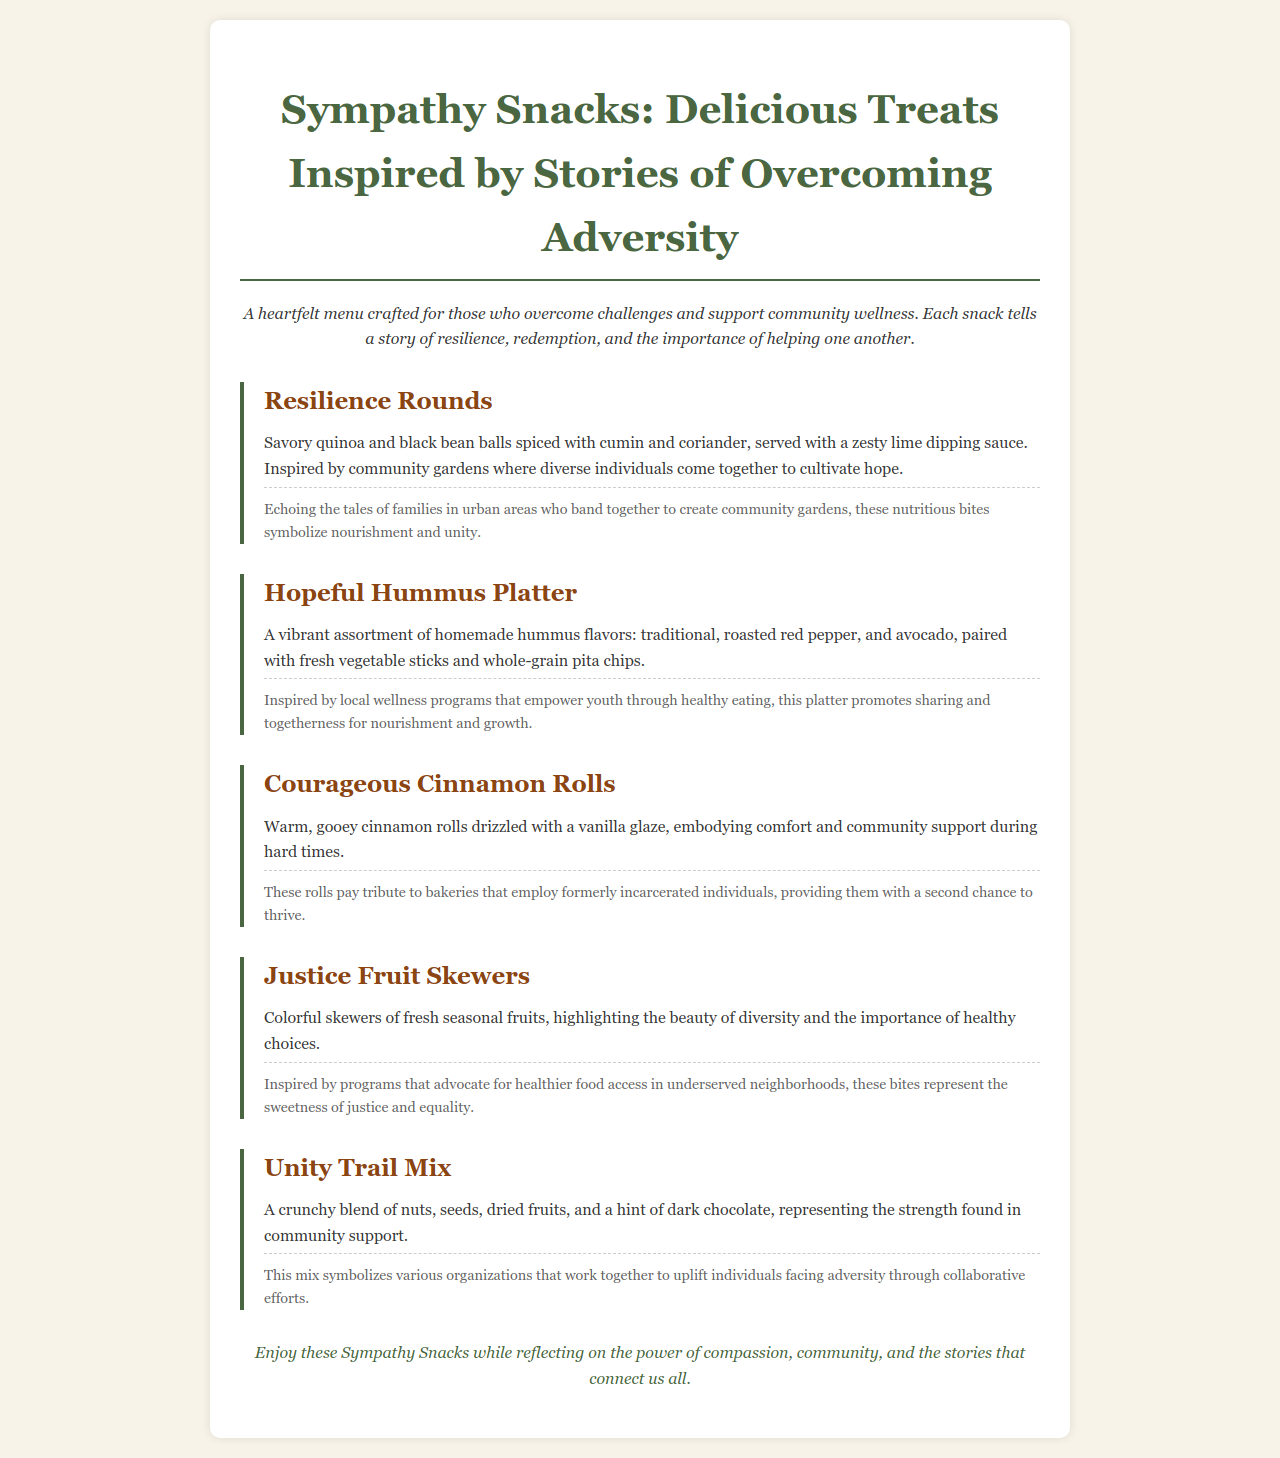What is the title of the menu? The title of the menu is given at the top of the document.
Answer: Sympathy Snacks: Delicious Treats Inspired by Stories of Overcoming Adversity How many snacks are featured on the menu? The number of snacks can be counted from the menu items listed.
Answer: Five What is included in the Resilience Rounds? The ingredients for Resilience Rounds are detailed within its description.
Answer: Quinoa and black bean balls, lime dipping sauce What does the Hopeful Hummus Platter promote? The purpose or theme of the Hopeful Hummus Platter is mentioned in its description.
Answer: Sharing and togetherness Which snack pays tribute to bakeries that employ formerly incarcerated individuals? This is specified in the description of one of the snacks.
Answer: Courageous Cinnamon Rolls What does the Unity Trail Mix symbolize? The symbolism related to the Unity Trail Mix is explained in its story.
Answer: Community support What is the overarching theme of the menu? The theme is mentioned in the introduction of the menu.
Answer: Compassion and community What type of fruits are used in the Justice Fruit Skewers? The specific type of items in the Justice Fruit Skewers can be referred to in the description.
Answer: Fresh seasonal fruits 